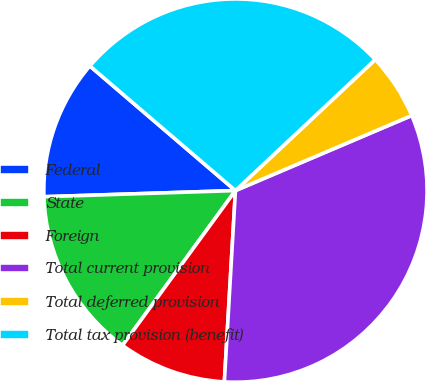<chart> <loc_0><loc_0><loc_500><loc_500><pie_chart><fcel>Federal<fcel>State<fcel>Foreign<fcel>Total current provision<fcel>Total deferred provision<fcel>Total tax provision (benefit)<nl><fcel>11.78%<fcel>14.46%<fcel>9.11%<fcel>32.33%<fcel>5.58%<fcel>26.75%<nl></chart> 